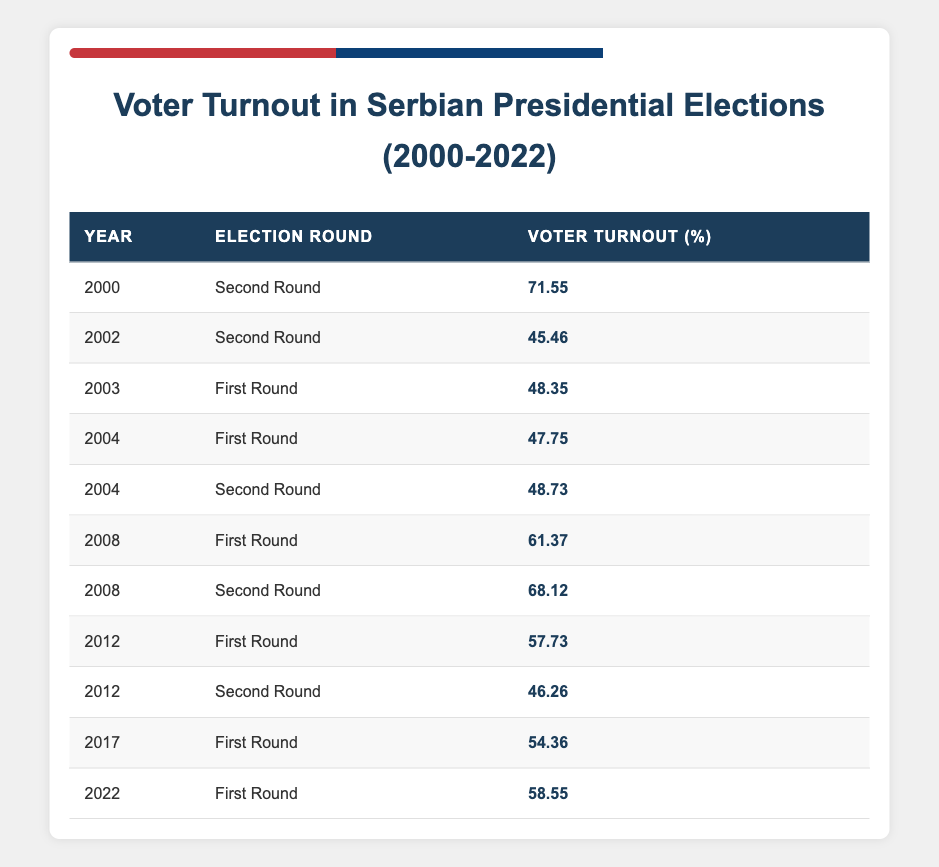What was the voter turnout percentage in the 2000 presidential election? In the table, the entry for the year 2000 is 71.55% voter turnout in the second round.
Answer: 71.55% What was the lowest voter turnout recorded in the elections from 2000 to 2022? Looking through the table, the lowest voter turnout percentage is 45.46% in the 2002 second round.
Answer: 45.46% How many elections had a voter turnout above 60%? By checking the table, the years with turnout above 60% are 2000 (71.55%), 2008 (61.37% and 68.12%), and 2012 (57.73%). This totals four instances.
Answer: 4 What is the average voter turnout across all years listed? To calculate it, add up all the voter turnout percentages: (71.55 + 45.46 + 48.35 + 47.75 + 48.73 + 61.37 + 68.12 + 57.73 + 46.26 + 54.36 + 58.55) = 508.64. Then, divide by the number of election rounds (11): 508.64 / 11 ≈ 46.24.
Answer: 46.24 Is it true that the voter turnout was higher in the first round of elections compared to the second round in 2008? In 2008, the first round had a turnout of 61.37%, while the second round had 68.12%. Therefore, the statement is false.
Answer: False Which year had the highest voter turnout for a first-round election? By checking the table, the year with the highest first-round turnout is 2008 with 61.37%.
Answer: 2008 What was the difference in voter turnout between the first and second rounds in 2004? For 2004, the first-round turnout was 47.75% and the second round was 48.73%. The difference is calculated as 48.73 - 47.75 = 0.98%.
Answer: 0.98% What percentage of the elections had a voter turnout of less than 50%? From the table, the elections below 50% turnout are 2002 (45.46%), 2003 (48.35%), 2004 (47.75%), and 2012 (46.26%), totaling four elections out of eleven, resulting in approximately 36.36%.
Answer: 36.36% 